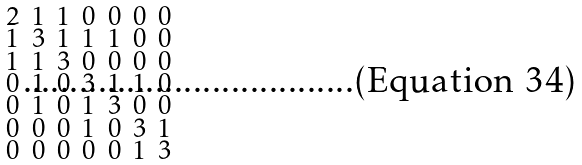<formula> <loc_0><loc_0><loc_500><loc_500>\begin{smallmatrix} 2 & 1 & 1 & 0 & 0 & 0 & 0 \\ 1 & 3 & 1 & 1 & 1 & 0 & 0 \\ 1 & 1 & 3 & 0 & 0 & 0 & 0 \\ 0 & 1 & 0 & 3 & 1 & 1 & 0 \\ 0 & 1 & 0 & 1 & 3 & 0 & 0 \\ 0 & 0 & 0 & 1 & 0 & 3 & 1 \\ 0 & 0 & 0 & 0 & 0 & 1 & 3 \end{smallmatrix}</formula> 